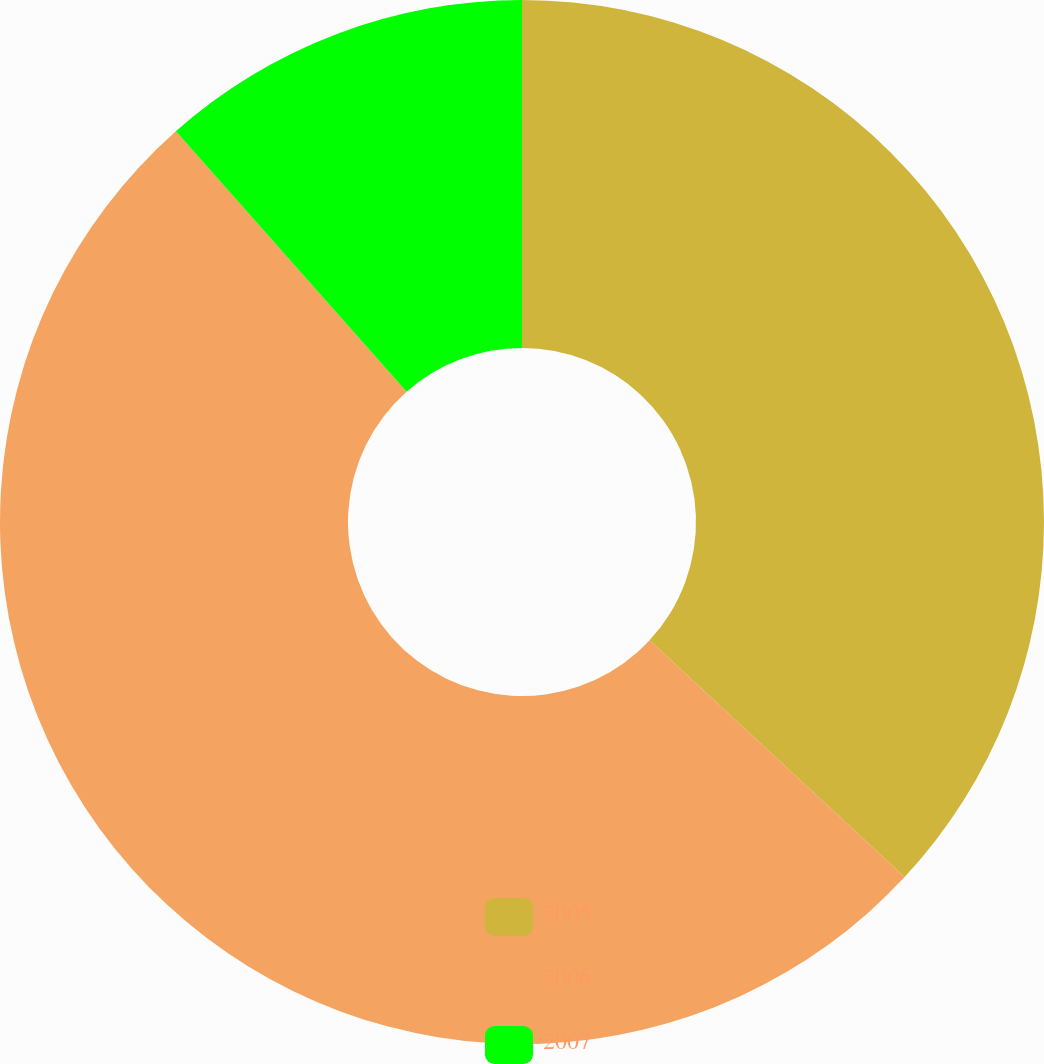Convert chart to OTSL. <chart><loc_0><loc_0><loc_500><loc_500><pie_chart><fcel>2005<fcel>2006<fcel>2007<nl><fcel>36.91%<fcel>51.56%<fcel>11.54%<nl></chart> 